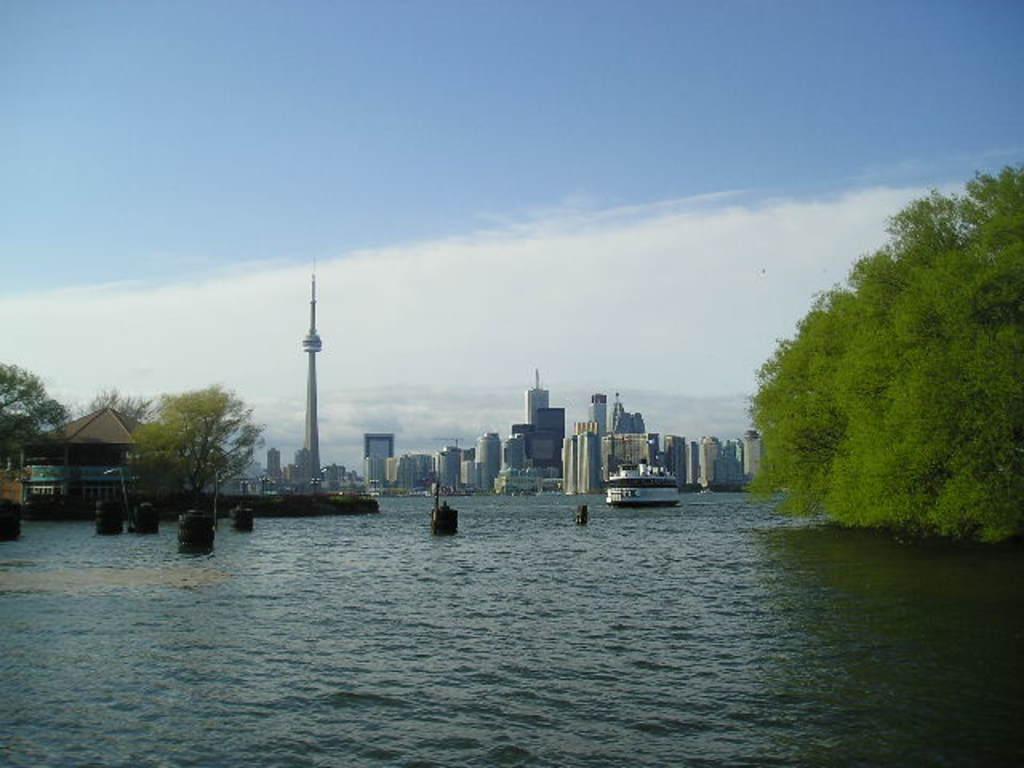Can you describe this image briefly? This picture is clicked outside the city. In the foreground we can see the ship and some other objects in the water body. In the center we can see the trees, buildings, skyscrapers and a minaret and on the left there are some objects. In the background there is a sky. 